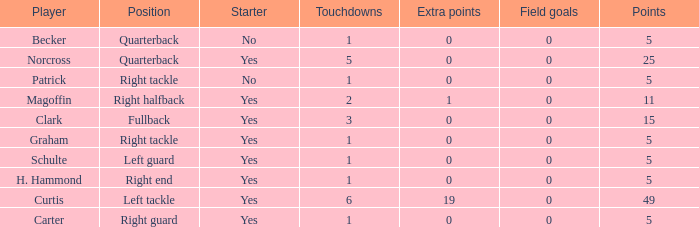Name the most touchdowns for becker  1.0. 